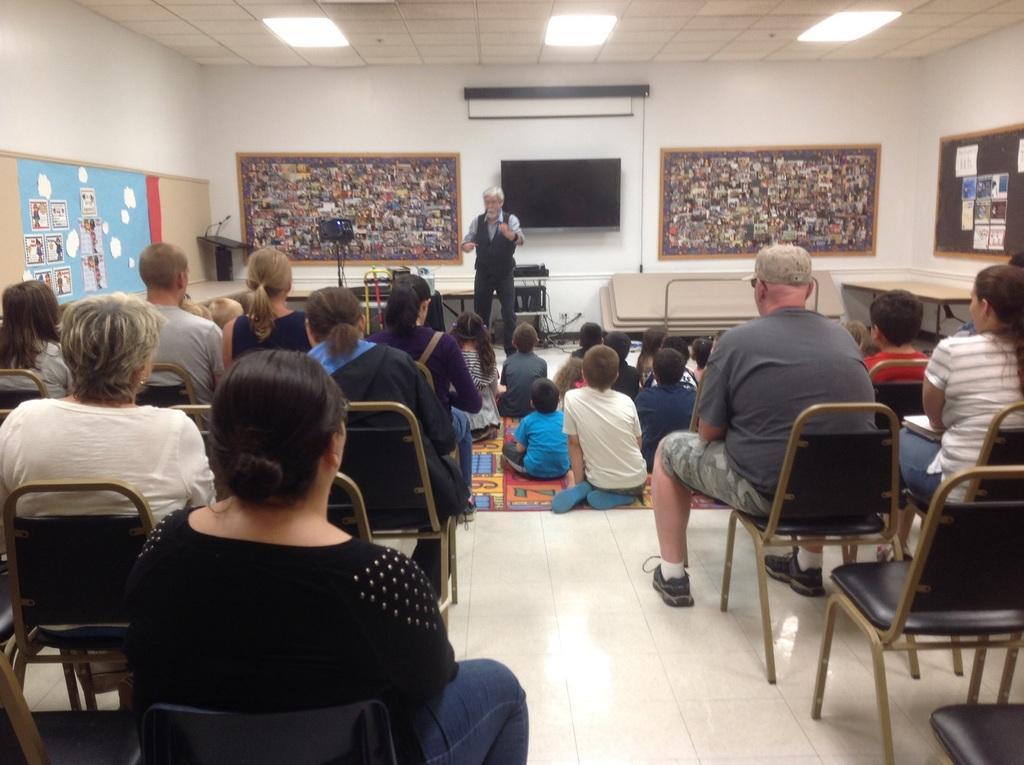How would you summarize this image in a sentence or two? people are seated on the chairs. in front of them children are sitting on the floor on a carpet. in front of them a person is standing and speaking. behind him there is a white wall on which there are 2 big photo frames and a television in the center. at the left and right there are 2 boards on which photos are attached. 